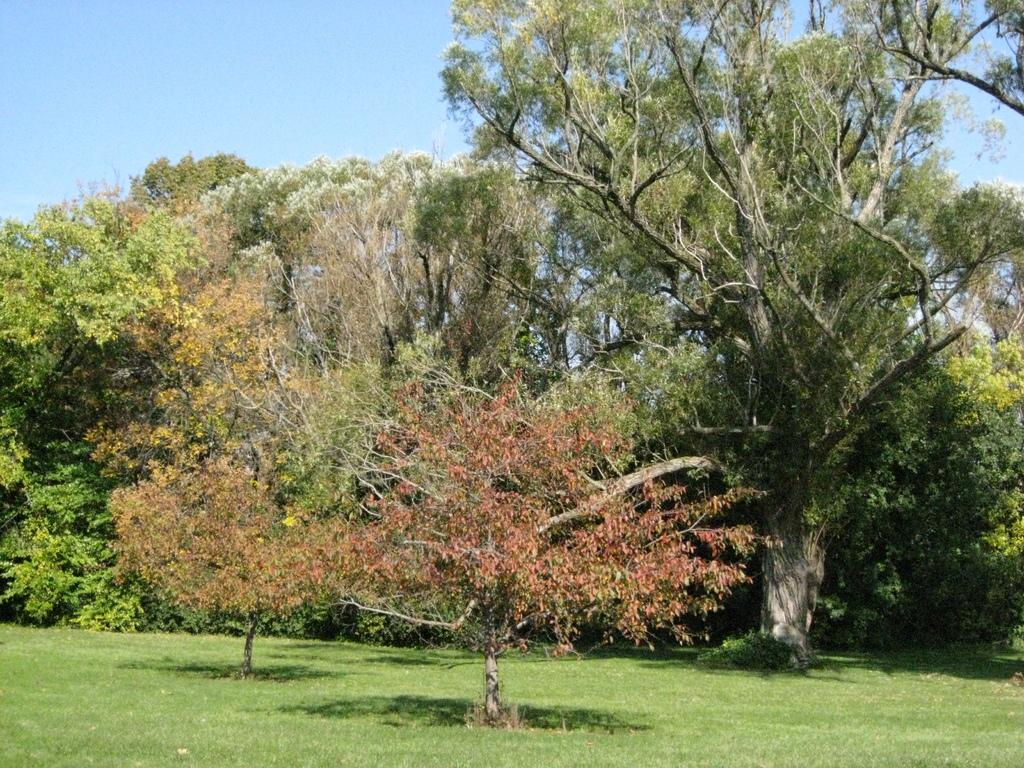What type of vegetation can be seen in the image? There are trees in the image. What colors are present on the trees in the image? The trees have red, yellow, green, and white colors. What can be seen in the background of the image? The blue sky is visible in the background of the image. What type of belief system is represented by the trees in the image? There is no indication of any belief system in the image; it simply features trees with various colors. 